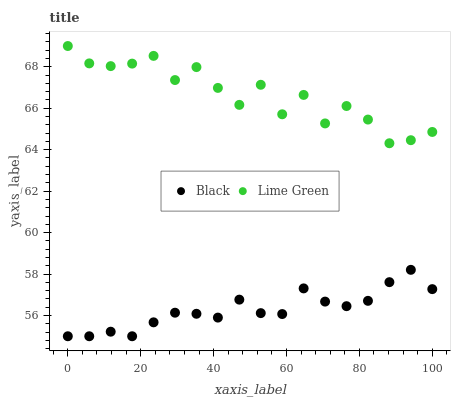Does Black have the minimum area under the curve?
Answer yes or no. Yes. Does Lime Green have the maximum area under the curve?
Answer yes or no. Yes. Does Black have the maximum area under the curve?
Answer yes or no. No. Is Black the smoothest?
Answer yes or no. Yes. Is Lime Green the roughest?
Answer yes or no. Yes. Is Black the roughest?
Answer yes or no. No. Does Black have the lowest value?
Answer yes or no. Yes. Does Lime Green have the highest value?
Answer yes or no. Yes. Does Black have the highest value?
Answer yes or no. No. Is Black less than Lime Green?
Answer yes or no. Yes. Is Lime Green greater than Black?
Answer yes or no. Yes. Does Black intersect Lime Green?
Answer yes or no. No. 